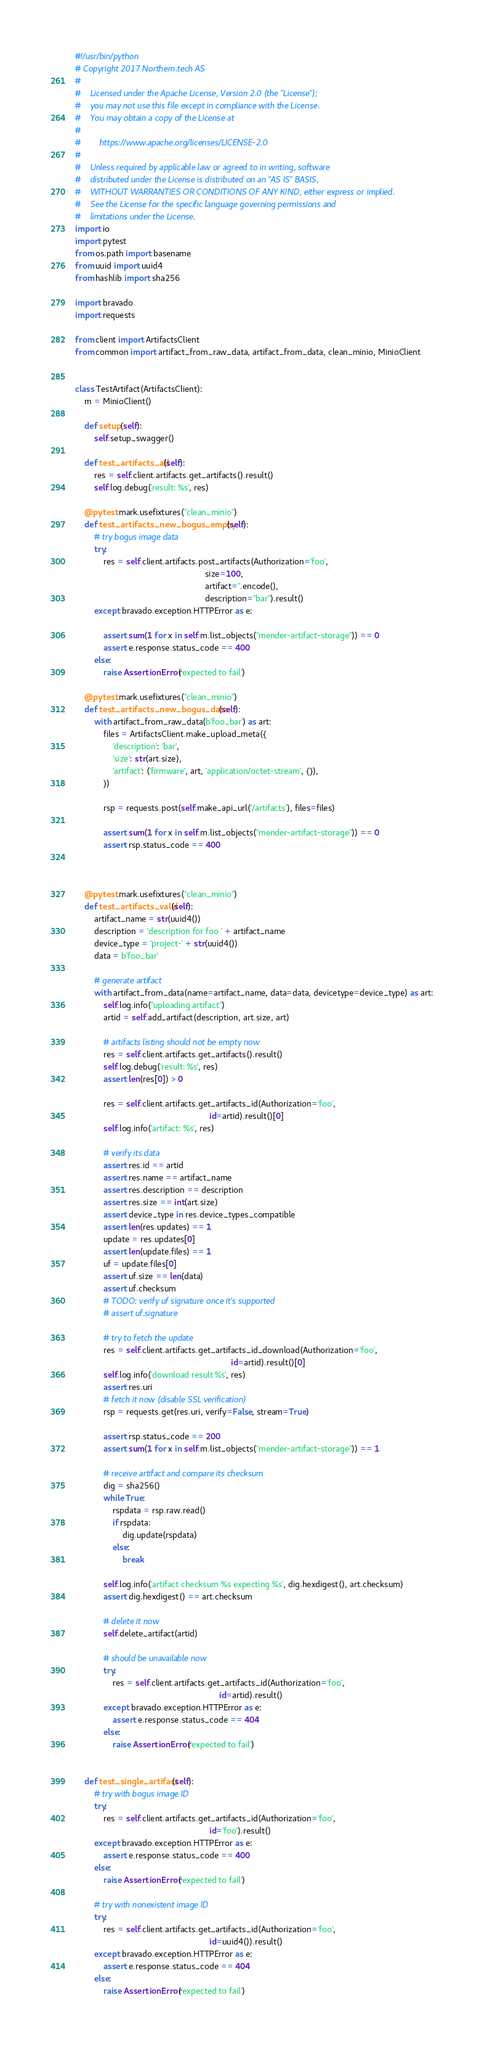<code> <loc_0><loc_0><loc_500><loc_500><_Python_>#!/usr/bin/python
# Copyright 2017 Northern.tech AS
#
#    Licensed under the Apache License, Version 2.0 (the "License");
#    you may not use this file except in compliance with the License.
#    You may obtain a copy of the License at
#
#        https://www.apache.org/licenses/LICENSE-2.0
#
#    Unless required by applicable law or agreed to in writing, software
#    distributed under the License is distributed on an "AS IS" BASIS,
#    WITHOUT WARRANTIES OR CONDITIONS OF ANY KIND, either express or implied.
#    See the License for the specific language governing permissions and
#    limitations under the License.
import io
import pytest
from os.path import basename
from uuid import uuid4
from hashlib import sha256

import bravado
import requests

from client import ArtifactsClient
from common import artifact_from_raw_data, artifact_from_data, clean_minio, MinioClient


class TestArtifact(ArtifactsClient):
    m = MinioClient()

    def setup(self):
        self.setup_swagger()

    def test_artifacts_all(self):
        res = self.client.artifacts.get_artifacts().result()
        self.log.debug('result: %s', res)

    @pytest.mark.usefixtures("clean_minio")
    def test_artifacts_new_bogus_empty(self):
        # try bogus image data
        try:
            res = self.client.artifacts.post_artifacts(Authorization='foo',
                                                       size=100,
                                                       artifact=''.encode(),
                                                       description="bar").result()
        except bravado.exception.HTTPError as e:

            assert sum(1 for x in self.m.list_objects("mender-artifact-storage")) == 0
            assert e.response.status_code == 400
        else:
            raise AssertionError('expected to fail')

    @pytest.mark.usefixtures("clean_minio")
    def test_artifacts_new_bogus_data(self):
        with artifact_from_raw_data(b'foo_bar') as art:
            files = ArtifactsClient.make_upload_meta({
                'description': 'bar',
                'size': str(art.size),
                'artifact': ('firmware', art, 'application/octet-stream', {}),
            })

            rsp = requests.post(self.make_api_url('/artifacts'), files=files)

            assert sum(1 for x in self.m.list_objects("mender-artifact-storage")) == 0
            assert rsp.status_code == 400



    @pytest.mark.usefixtures("clean_minio")
    def test_artifacts_valid(self):
        artifact_name = str(uuid4())
        description = 'description for foo ' + artifact_name
        device_type = 'project-' + str(uuid4())
        data = b'foo_bar'

        # generate artifact
        with artifact_from_data(name=artifact_name, data=data, devicetype=device_type) as art:
            self.log.info("uploading artifact")
            artid = self.add_artifact(description, art.size, art)

            # artifacts listing should not be empty now
            res = self.client.artifacts.get_artifacts().result()
            self.log.debug('result: %s', res)
            assert len(res[0]) > 0

            res = self.client.artifacts.get_artifacts_id(Authorization='foo',
                                                         id=artid).result()[0]
            self.log.info('artifact: %s', res)

            # verify its data
            assert res.id == artid
            assert res.name == artifact_name
            assert res.description == description
            assert res.size == int(art.size)
            assert device_type in res.device_types_compatible
            assert len(res.updates) == 1
            update = res.updates[0]
            assert len(update.files) == 1
            uf = update.files[0]
            assert uf.size == len(data)
            assert uf.checksum
            # TODO: verify uf signature once it's supported
            # assert uf.signature

            # try to fetch the update
            res = self.client.artifacts.get_artifacts_id_download(Authorization='foo',
                                                                  id=artid).result()[0]
            self.log.info('download result %s', res)
            assert res.uri
            # fetch it now (disable SSL verification)
            rsp = requests.get(res.uri, verify=False, stream=True)

            assert rsp.status_code == 200
            assert sum(1 for x in self.m.list_objects("mender-artifact-storage")) == 1

            # receive artifact and compare its checksum
            dig = sha256()
            while True:
                rspdata = rsp.raw.read()
                if rspdata:
                    dig.update(rspdata)
                else:
                    break

            self.log.info('artifact checksum %s expecting %s', dig.hexdigest(), art.checksum)
            assert dig.hexdigest() == art.checksum

            # delete it now
            self.delete_artifact(artid)

            # should be unavailable now
            try:
                res = self.client.artifacts.get_artifacts_id(Authorization='foo',
                                                             id=artid).result()
            except bravado.exception.HTTPError as e:
                assert e.response.status_code == 404
            else:
                raise AssertionError('expected to fail')


    def test_single_artifact(self):
        # try with bogus image ID
        try:
            res = self.client.artifacts.get_artifacts_id(Authorization='foo',
                                                         id='foo').result()
        except bravado.exception.HTTPError as e:
            assert e.response.status_code == 400
        else:
            raise AssertionError('expected to fail')

        # try with nonexistent image ID
        try:
            res = self.client.artifacts.get_artifacts_id(Authorization='foo',
                                                         id=uuid4()).result()
        except bravado.exception.HTTPError as e:
            assert e.response.status_code == 404
        else:
            raise AssertionError('expected to fail')
</code> 